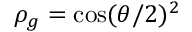Convert formula to latex. <formula><loc_0><loc_0><loc_500><loc_500>\rho _ { g } = \cos ( \theta / 2 ) ^ { 2 }</formula> 